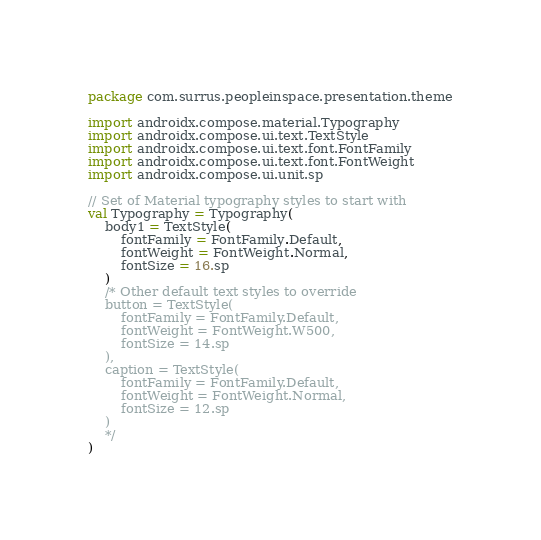<code> <loc_0><loc_0><loc_500><loc_500><_Kotlin_>package com.surrus.peopleinspace.presentation.theme

import androidx.compose.material.Typography
import androidx.compose.ui.text.TextStyle
import androidx.compose.ui.text.font.FontFamily
import androidx.compose.ui.text.font.FontWeight
import androidx.compose.ui.unit.sp

// Set of Material typography styles to start with
val Typography = Typography(
    body1 = TextStyle(
        fontFamily = FontFamily.Default,
        fontWeight = FontWeight.Normal,
        fontSize = 16.sp
    )
    /* Other default text styles to override
    button = TextStyle(
        fontFamily = FontFamily.Default,
        fontWeight = FontWeight.W500,
        fontSize = 14.sp
    ),
    caption = TextStyle(
        fontFamily = FontFamily.Default,
        fontWeight = FontWeight.Normal,
        fontSize = 12.sp
    )
    */
)
</code> 